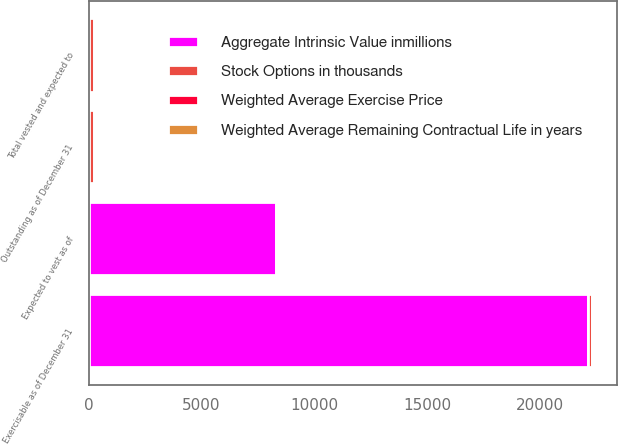Convert chart to OTSL. <chart><loc_0><loc_0><loc_500><loc_500><stacked_bar_chart><ecel><fcel>Outstanding as of December 31<fcel>Exercisable as of December 31<fcel>Expected to vest as of<fcel>Total vested and expected to<nl><fcel>Aggregate Intrinsic Value inmillions<fcel>12<fcel>22104<fcel>8299<fcel>12<nl><fcel>Weighted Average Remaining Contractual Life in years<fcel>11<fcel>10<fcel>13<fcel>11<nl><fcel>Weighted Average Exercise Price<fcel>5.3<fcel>4<fcel>8.4<fcel>5.2<nl><fcel>Stock Options in thousands<fcel>240<fcel>196<fcel>42<fcel>238<nl></chart> 